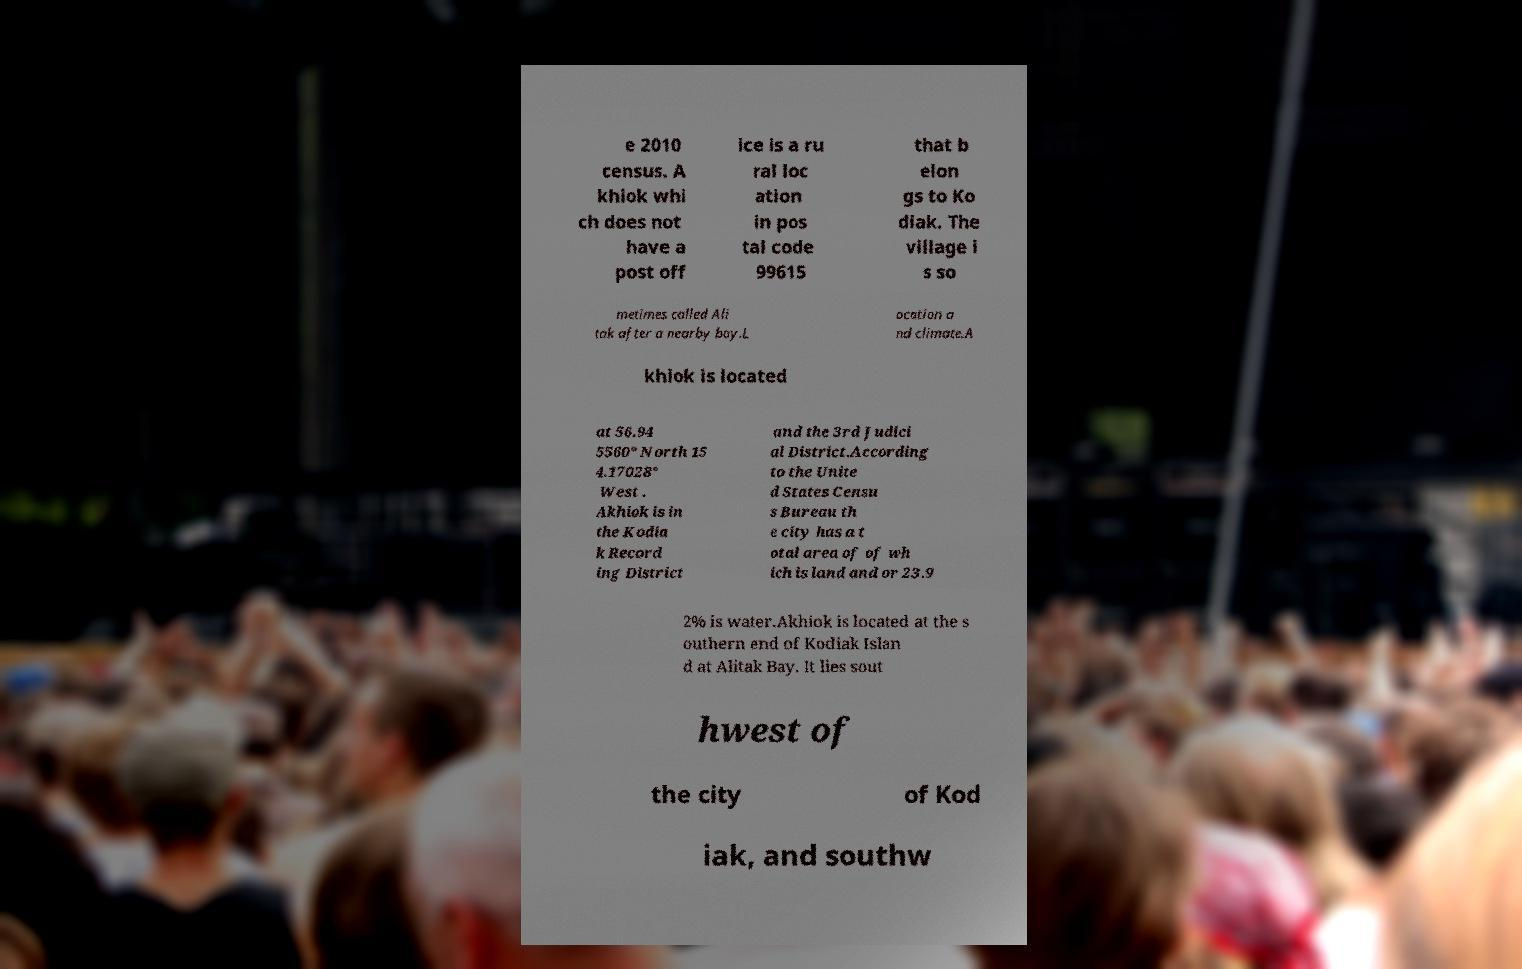Could you extract and type out the text from this image? e 2010 census. A khiok whi ch does not have a post off ice is a ru ral loc ation in pos tal code 99615 that b elon gs to Ko diak. The village i s so metimes called Ali tak after a nearby bay.L ocation a nd climate.A khiok is located at 56.94 5560° North 15 4.17028° West . Akhiok is in the Kodia k Record ing District and the 3rd Judici al District.According to the Unite d States Censu s Bureau th e city has a t otal area of of wh ich is land and or 23.9 2% is water.Akhiok is located at the s outhern end of Kodiak Islan d at Alitak Bay. It lies sout hwest of the city of Kod iak, and southw 